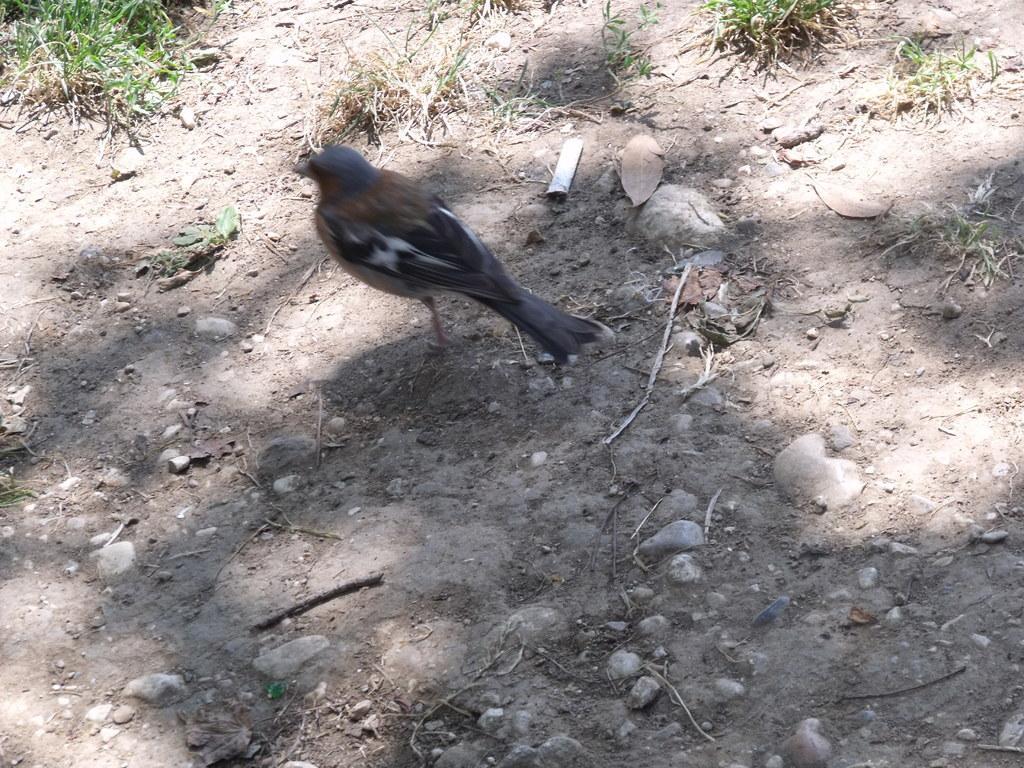Describe this image in one or two sentences. In this image we can see a bird. In the background we can see the land, stones, grass and also the dried stems. 